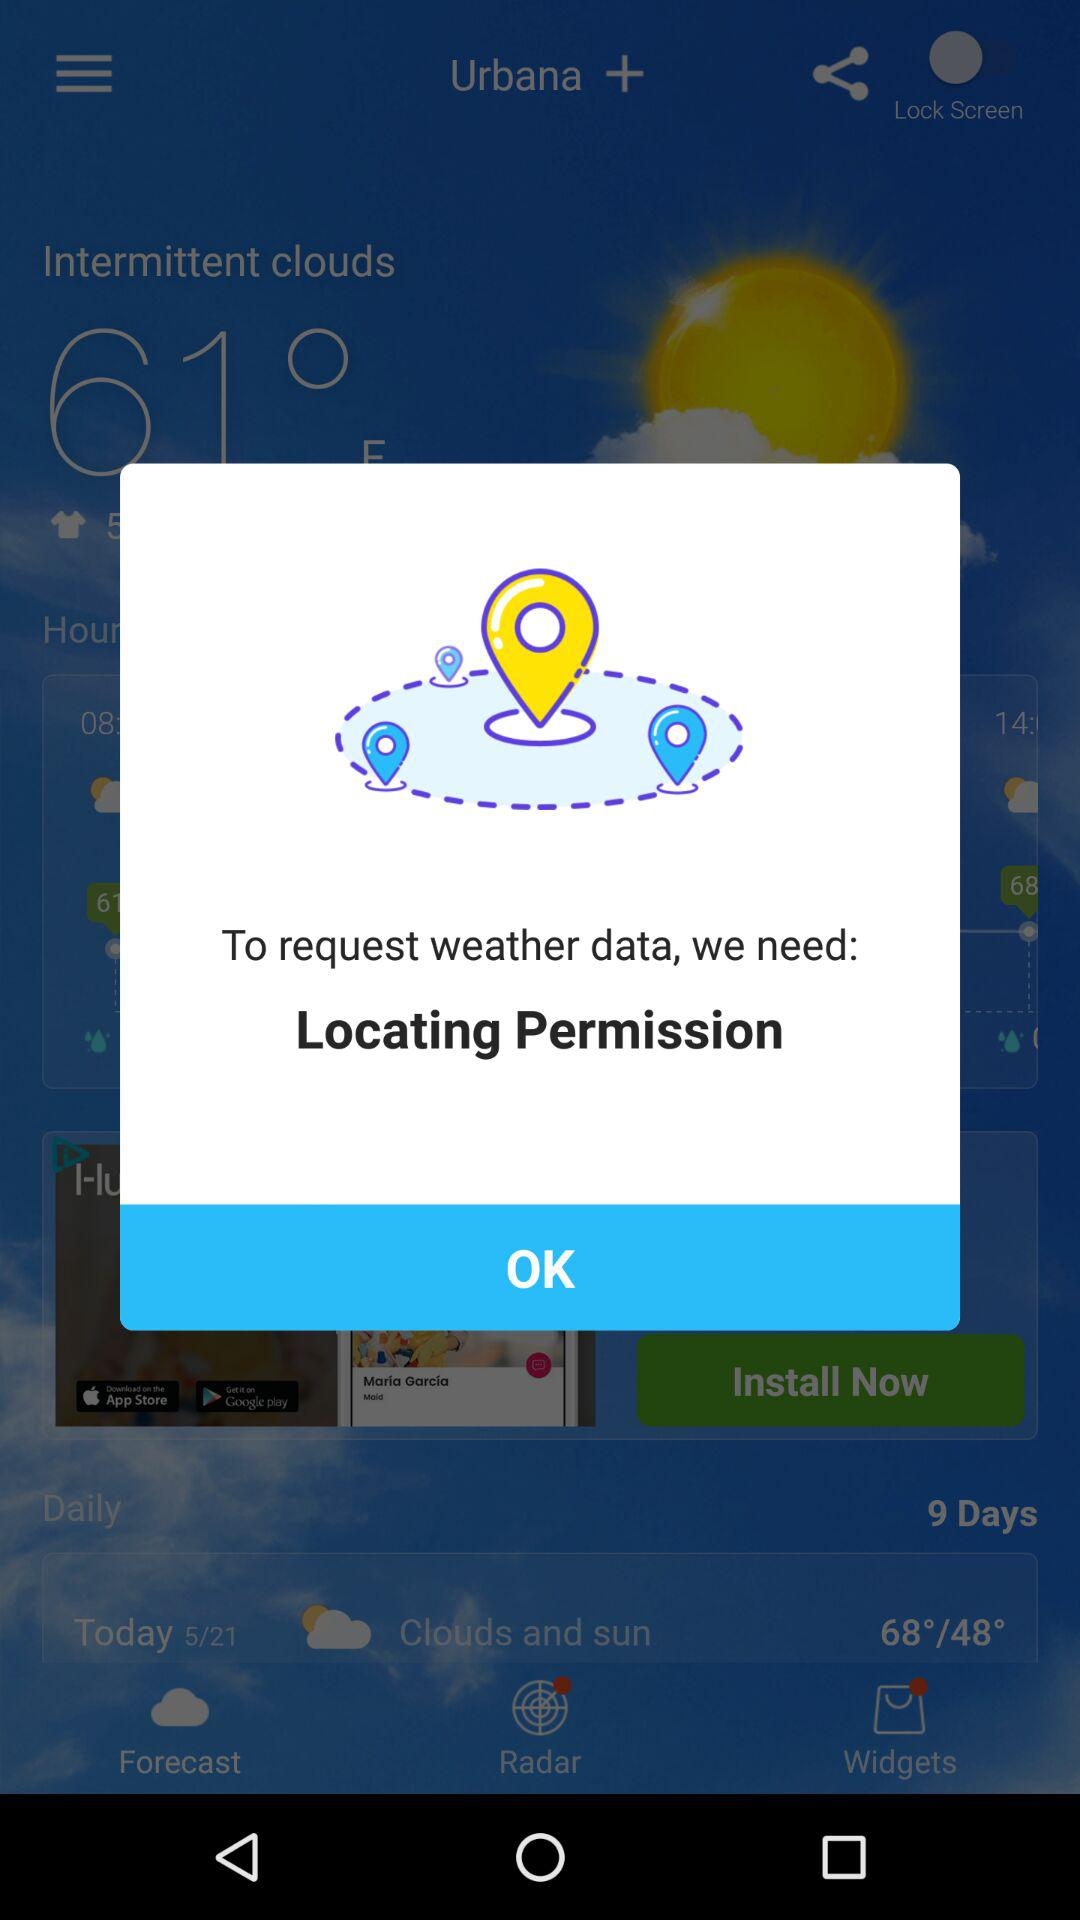What is the today's temperature?
When the provided information is insufficient, respond with <no answer>. <no answer> 